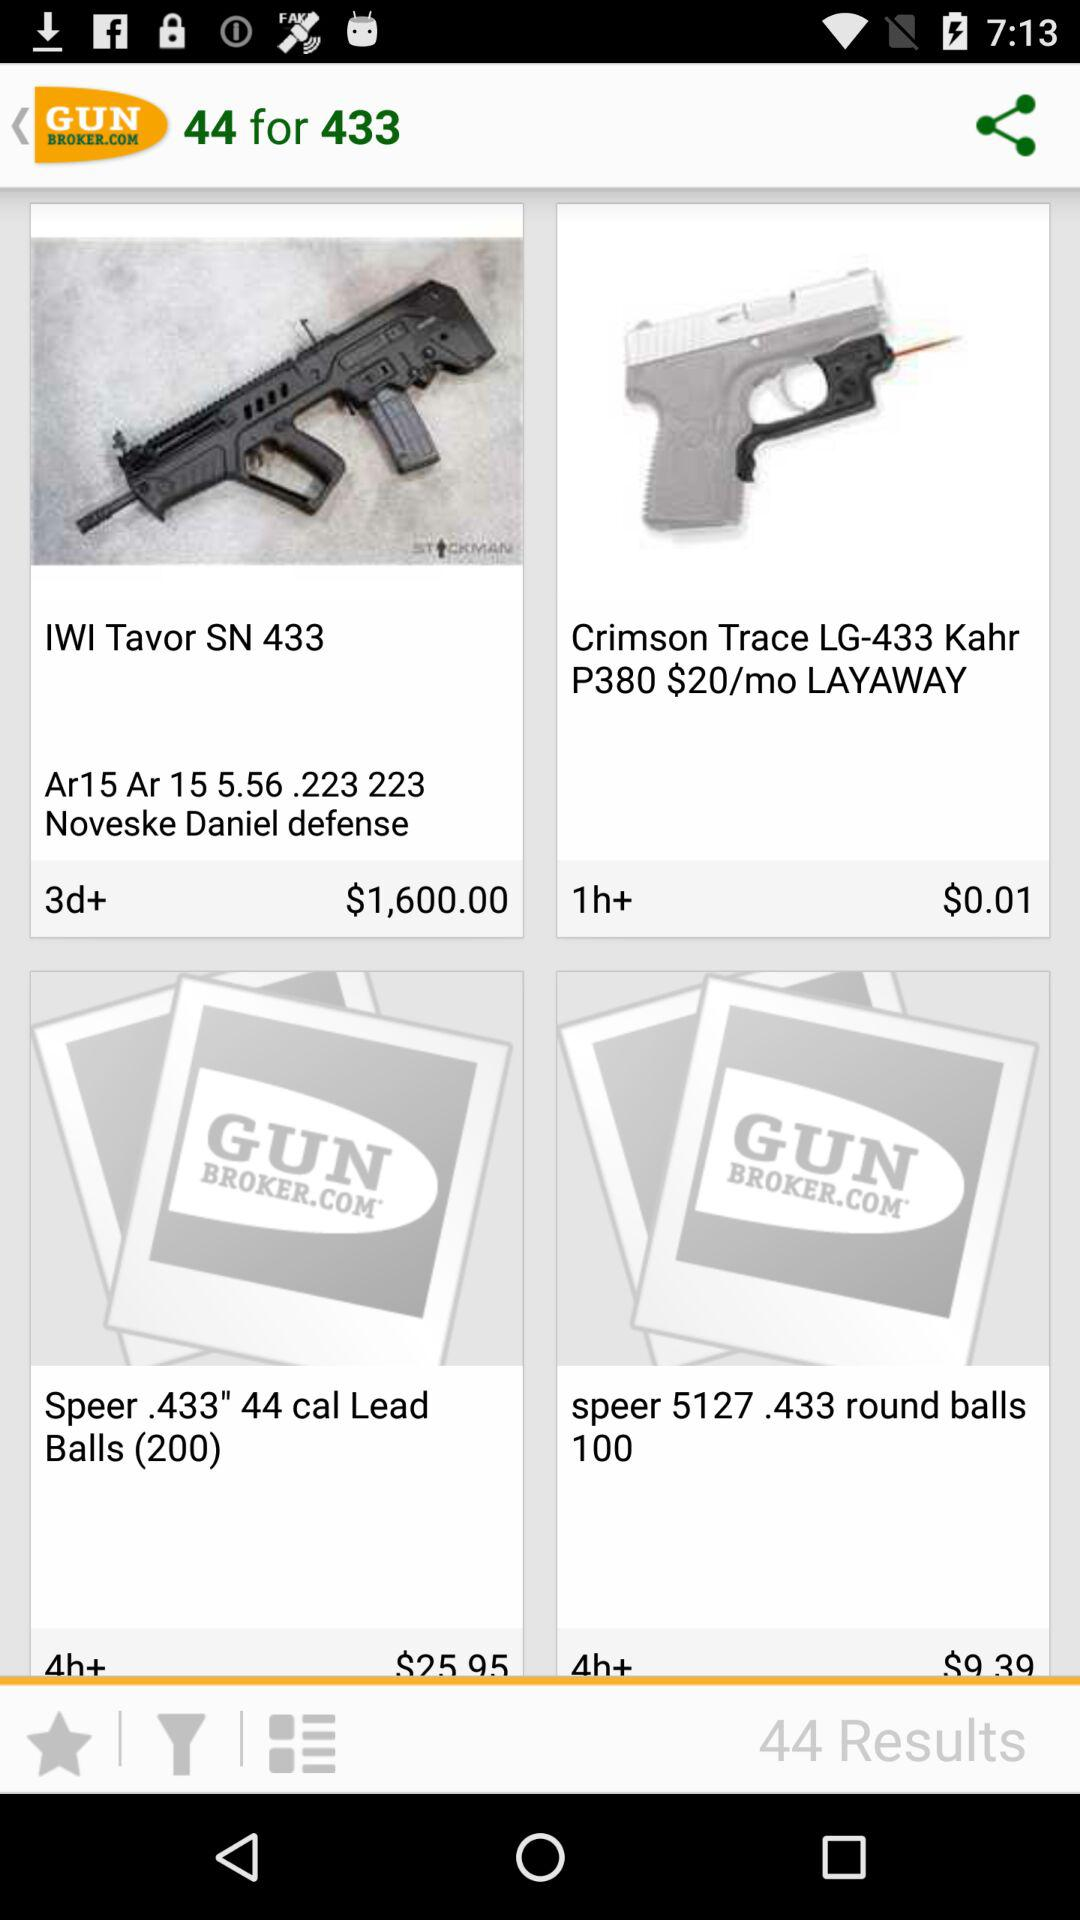What is the price of "Crimson Trace LG-433 Kahr P380 $20/mo LAYAWAY"? The price of "Crimson Trace LG-433 Kahr P380 $20/mo LAYAWAY" is $0.01. 